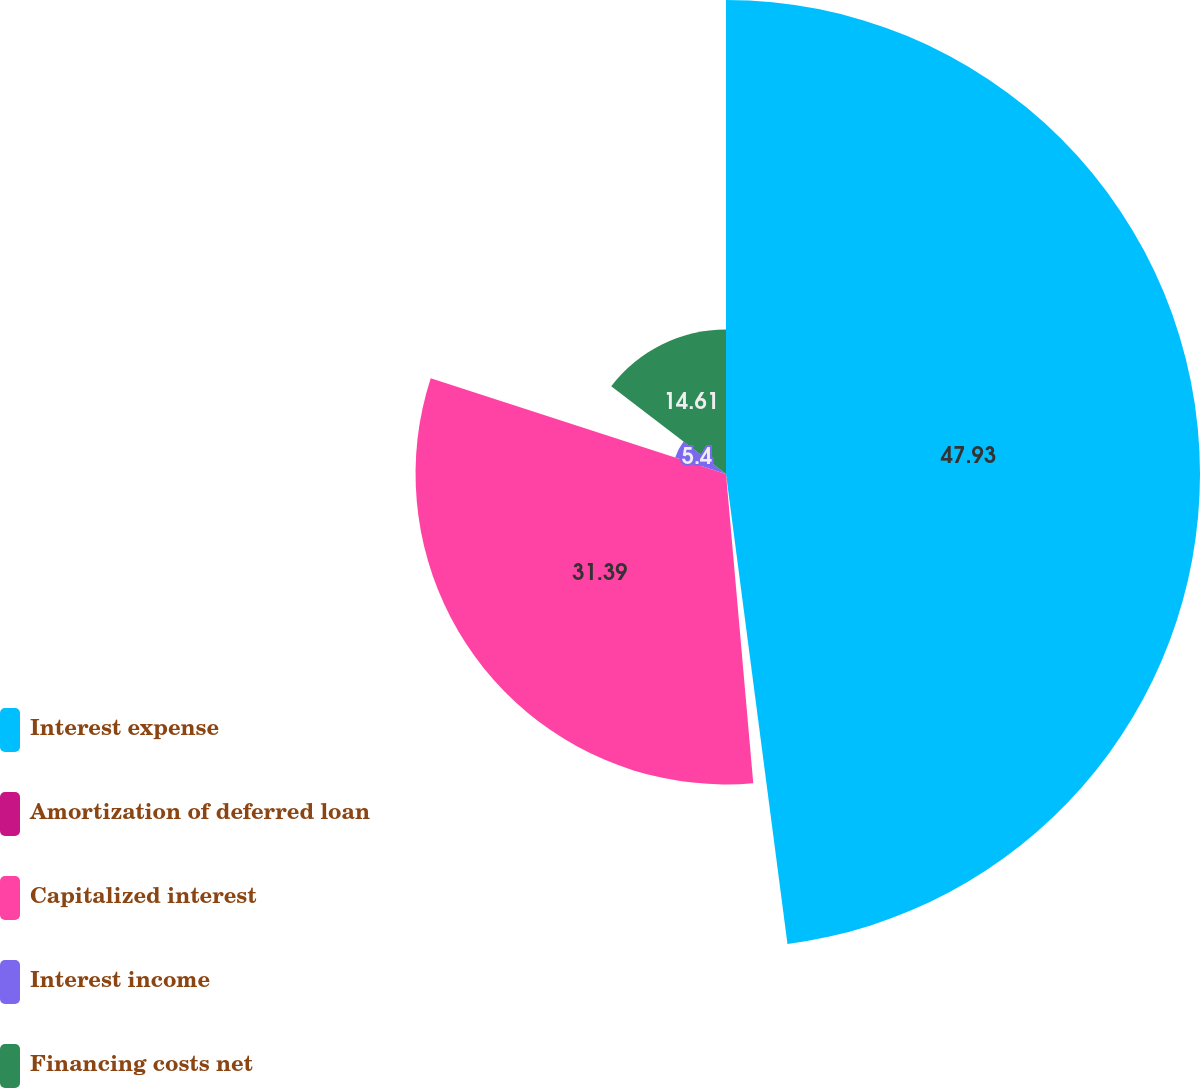Convert chart to OTSL. <chart><loc_0><loc_0><loc_500><loc_500><pie_chart><fcel>Interest expense<fcel>Amortization of deferred loan<fcel>Capitalized interest<fcel>Interest income<fcel>Financing costs net<nl><fcel>47.93%<fcel>0.67%<fcel>31.39%<fcel>5.4%<fcel>14.61%<nl></chart> 